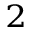<formula> <loc_0><loc_0><loc_500><loc_500>_ { 2 }</formula> 